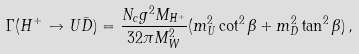Convert formula to latex. <formula><loc_0><loc_0><loc_500><loc_500>\Gamma ( H ^ { + } \to U \bar { D } ) = \frac { N _ { c } g ^ { 2 } M _ { H ^ { + } } } { 3 2 \pi M ^ { 2 } _ { W } } ( m ^ { 2 } _ { U } \cot ^ { 2 } { \beta } + m ^ { 2 } _ { D } \tan ^ { 2 } { \beta } ) \, ,</formula> 